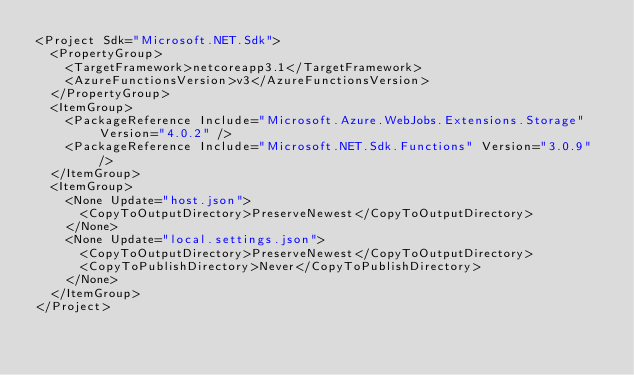<code> <loc_0><loc_0><loc_500><loc_500><_XML_><Project Sdk="Microsoft.NET.Sdk">
  <PropertyGroup>
    <TargetFramework>netcoreapp3.1</TargetFramework>
    <AzureFunctionsVersion>v3</AzureFunctionsVersion>
  </PropertyGroup>
  <ItemGroup>
    <PackageReference Include="Microsoft.Azure.WebJobs.Extensions.Storage" Version="4.0.2" />
    <PackageReference Include="Microsoft.NET.Sdk.Functions" Version="3.0.9" />
  </ItemGroup>
  <ItemGroup>
    <None Update="host.json">
      <CopyToOutputDirectory>PreserveNewest</CopyToOutputDirectory>
    </None>
    <None Update="local.settings.json">
      <CopyToOutputDirectory>PreserveNewest</CopyToOutputDirectory>
      <CopyToPublishDirectory>Never</CopyToPublishDirectory>
    </None>
  </ItemGroup>
</Project></code> 